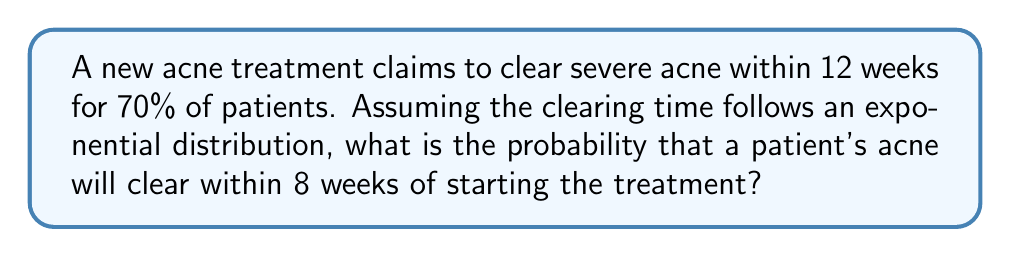Can you solve this math problem? To solve this problem, we'll use the properties of the exponential distribution and the given information:

1. The probability of clearing within 12 weeks is 0.70 (70%)
2. We need to find the probability of clearing within 8 weeks

Let's approach this step-by-step:

1. For an exponential distribution, the cumulative distribution function is:
   
   $F(t) = 1 - e^{-\lambda t}$

   where $\lambda$ is the rate parameter and $t$ is the time.

2. We can find $\lambda$ using the given information:

   $0.70 = 1 - e^{-\lambda \cdot 12}$

3. Solving for $\lambda$:
   
   $e^{-12\lambda} = 0.30$
   $-12\lambda = \ln(0.30)$
   $\lambda = -\frac{\ln(0.30)}{12} \approx 0.1004$

4. Now that we have $\lambda$, we can calculate the probability of clearing within 8 weeks:

   $P(T \leq 8) = 1 - e^{-\lambda \cdot 8}$
   
   $= 1 - e^{-0.1004 \cdot 8}$
   
   $= 1 - e^{-0.8032}$
   
   $= 1 - 0.4478$
   
   $= 0.5522$

Therefore, the probability of the acne clearing within 8 weeks is approximately 0.5522 or 55.22%.
Answer: The probability that a patient's acne will clear within 8 weeks of starting the treatment is approximately 0.5522 or 55.22%. 